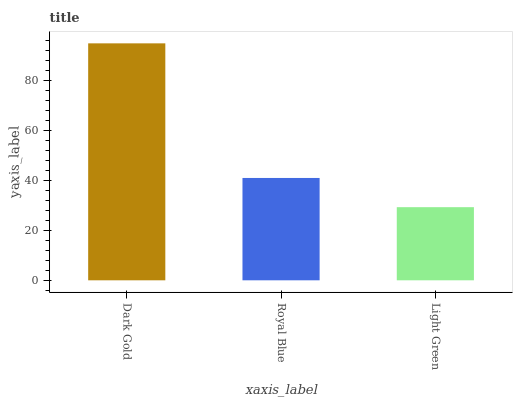Is Light Green the minimum?
Answer yes or no. Yes. Is Dark Gold the maximum?
Answer yes or no. Yes. Is Royal Blue the minimum?
Answer yes or no. No. Is Royal Blue the maximum?
Answer yes or no. No. Is Dark Gold greater than Royal Blue?
Answer yes or no. Yes. Is Royal Blue less than Dark Gold?
Answer yes or no. Yes. Is Royal Blue greater than Dark Gold?
Answer yes or no. No. Is Dark Gold less than Royal Blue?
Answer yes or no. No. Is Royal Blue the high median?
Answer yes or no. Yes. Is Royal Blue the low median?
Answer yes or no. Yes. Is Dark Gold the high median?
Answer yes or no. No. Is Dark Gold the low median?
Answer yes or no. No. 